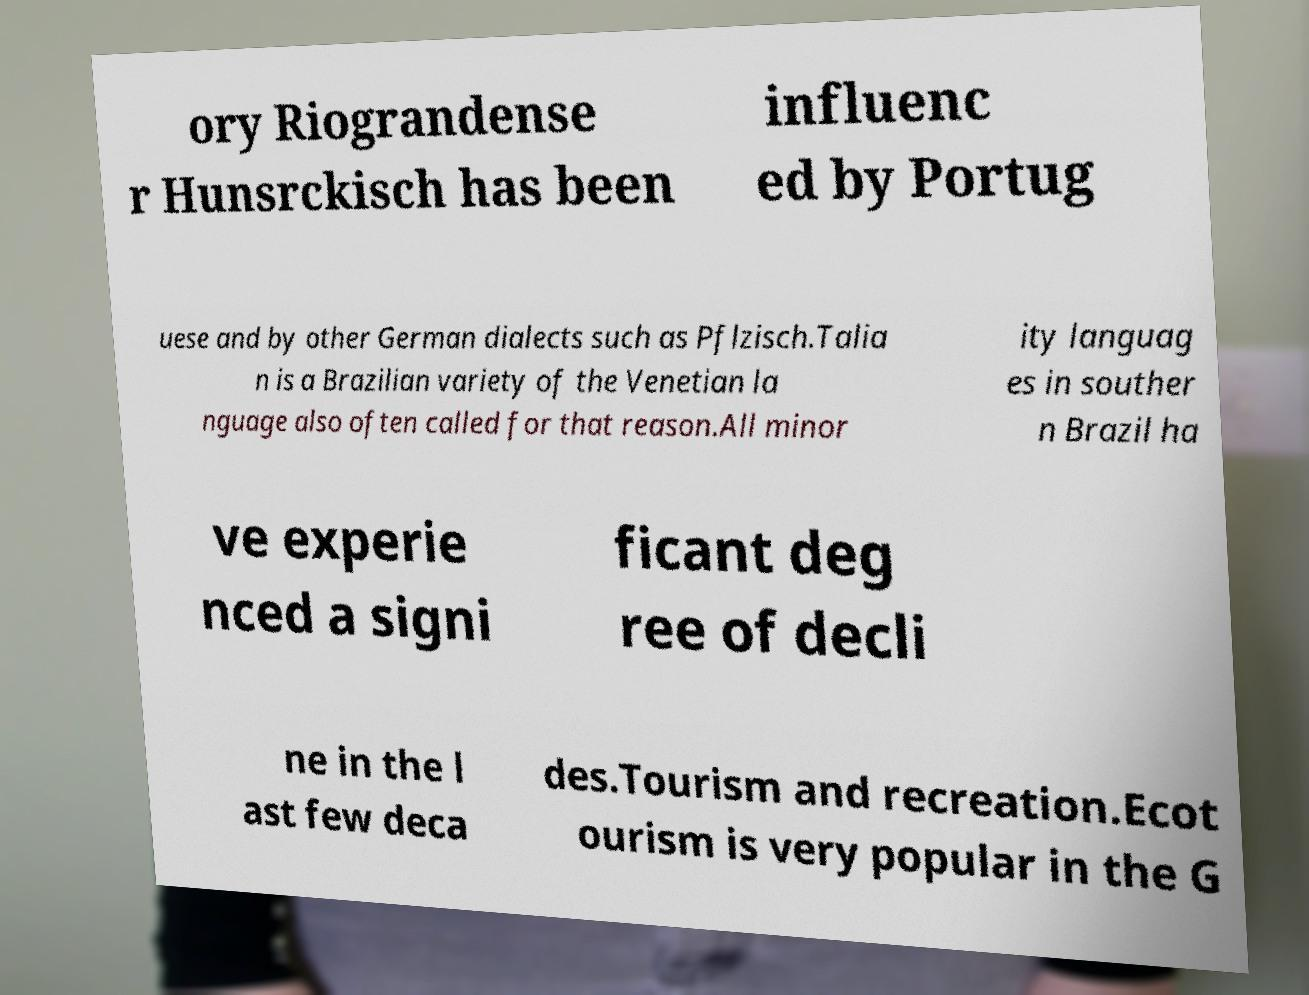For documentation purposes, I need the text within this image transcribed. Could you provide that? ory Riograndense r Hunsrckisch has been influenc ed by Portug uese and by other German dialects such as Pflzisch.Talia n is a Brazilian variety of the Venetian la nguage also often called for that reason.All minor ity languag es in souther n Brazil ha ve experie nced a signi ficant deg ree of decli ne in the l ast few deca des.Tourism and recreation.Ecot ourism is very popular in the G 